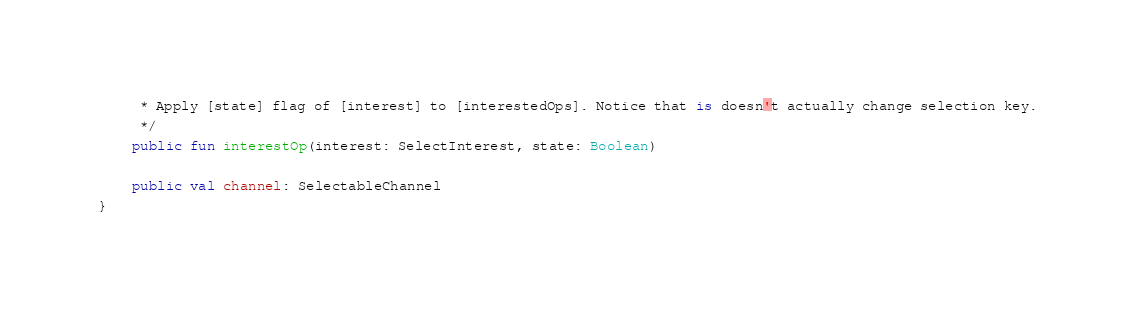<code> <loc_0><loc_0><loc_500><loc_500><_Kotlin_>     * Apply [state] flag of [interest] to [interestedOps]. Notice that is doesn't actually change selection key.
     */
    public fun interestOp(interest: SelectInterest, state: Boolean)

    public val channel: SelectableChannel
}
</code> 